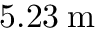<formula> <loc_0><loc_0><loc_500><loc_500>5 . 2 3 \, m</formula> 